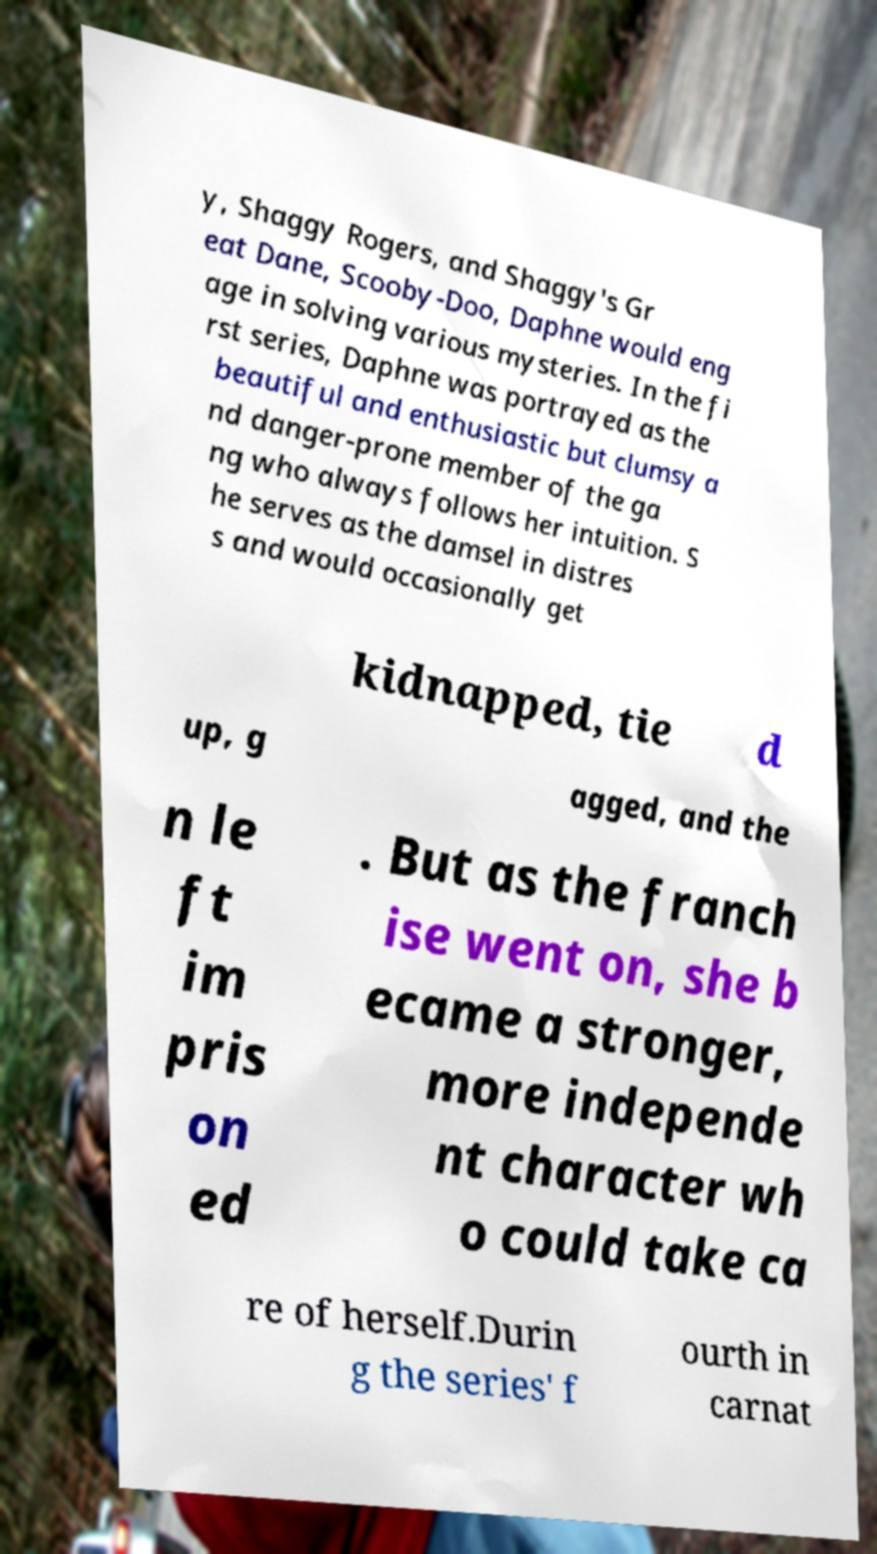I need the written content from this picture converted into text. Can you do that? y, Shaggy Rogers, and Shaggy's Gr eat Dane, Scooby-Doo, Daphne would eng age in solving various mysteries. In the fi rst series, Daphne was portrayed as the beautiful and enthusiastic but clumsy a nd danger-prone member of the ga ng who always follows her intuition. S he serves as the damsel in distres s and would occasionally get kidnapped, tie d up, g agged, and the n le ft im pris on ed . But as the franch ise went on, she b ecame a stronger, more independe nt character wh o could take ca re of herself.Durin g the series' f ourth in carnat 